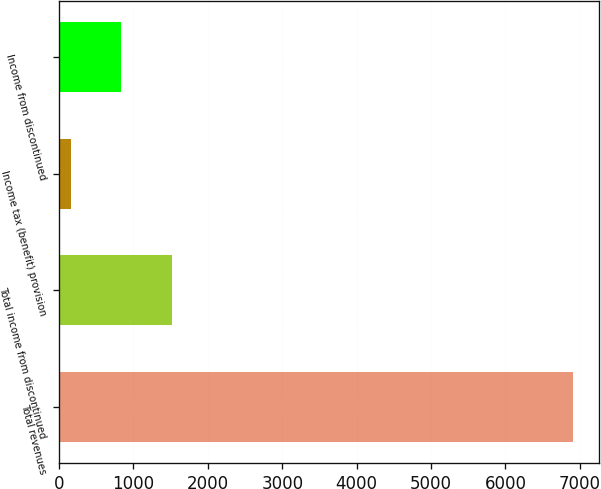<chart> <loc_0><loc_0><loc_500><loc_500><bar_chart><fcel>Total revenues<fcel>Total income from discontinued<fcel>Income tax (benefit) provision<fcel>Income from discontinued<nl><fcel>6909<fcel>1513<fcel>164<fcel>838.5<nl></chart> 